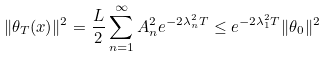Convert formula to latex. <formula><loc_0><loc_0><loc_500><loc_500>\| \theta _ { T } ( x ) \| ^ { 2 } = \frac { L } { 2 } \sum _ { n = 1 } ^ { \infty } A _ { n } ^ { 2 } e ^ { - 2 \lambda _ { n } ^ { 2 } T } \leq e ^ { - 2 \lambda _ { 1 } ^ { 2 } T } \| \theta _ { 0 } \| ^ { 2 }</formula> 